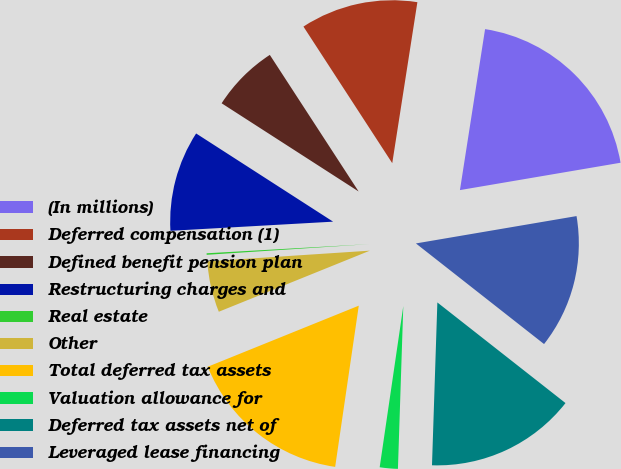<chart> <loc_0><loc_0><loc_500><loc_500><pie_chart><fcel>(In millions)<fcel>Deferred compensation (1)<fcel>Defined benefit pension plan<fcel>Restructuring charges and<fcel>Real estate<fcel>Other<fcel>Total deferred tax assets<fcel>Valuation allowance for<fcel>Deferred tax assets net of<fcel>Leveraged lease financing<nl><fcel>19.85%<fcel>11.64%<fcel>6.72%<fcel>10.0%<fcel>0.15%<fcel>5.07%<fcel>16.57%<fcel>1.79%<fcel>14.93%<fcel>13.28%<nl></chart> 